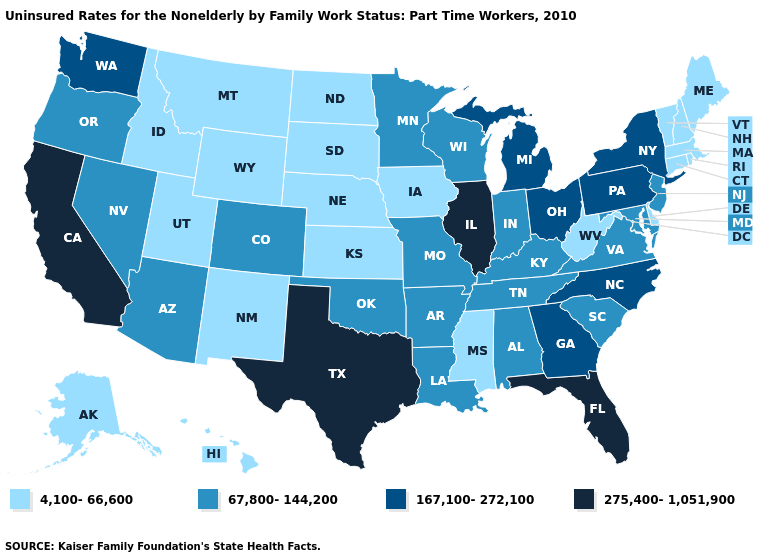What is the lowest value in the USA?
Short answer required. 4,100-66,600. What is the value of New Jersey?
Be succinct. 67,800-144,200. What is the lowest value in the South?
Be succinct. 4,100-66,600. What is the highest value in the West ?
Keep it brief. 275,400-1,051,900. What is the lowest value in the West?
Give a very brief answer. 4,100-66,600. What is the lowest value in states that border New Jersey?
Keep it brief. 4,100-66,600. Name the states that have a value in the range 67,800-144,200?
Keep it brief. Alabama, Arizona, Arkansas, Colorado, Indiana, Kentucky, Louisiana, Maryland, Minnesota, Missouri, Nevada, New Jersey, Oklahoma, Oregon, South Carolina, Tennessee, Virginia, Wisconsin. What is the value of Massachusetts?
Quick response, please. 4,100-66,600. What is the value of Kansas?
Answer briefly. 4,100-66,600. Among the states that border Iowa , does Minnesota have the lowest value?
Keep it brief. No. Name the states that have a value in the range 4,100-66,600?
Give a very brief answer. Alaska, Connecticut, Delaware, Hawaii, Idaho, Iowa, Kansas, Maine, Massachusetts, Mississippi, Montana, Nebraska, New Hampshire, New Mexico, North Dakota, Rhode Island, South Dakota, Utah, Vermont, West Virginia, Wyoming. What is the value of Indiana?
Give a very brief answer. 67,800-144,200. Name the states that have a value in the range 275,400-1,051,900?
Write a very short answer. California, Florida, Illinois, Texas. What is the highest value in states that border Rhode Island?
Keep it brief. 4,100-66,600. 